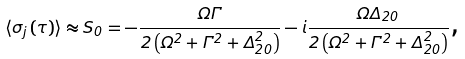<formula> <loc_0><loc_0><loc_500><loc_500>\langle \sigma _ { j } \left ( \tau \right ) \rangle \approx S _ { 0 } = - \frac { \Omega \Gamma } { 2 \left ( \Omega ^ { 2 } + \Gamma ^ { 2 } + \Delta _ { 2 0 } ^ { 2 } \right ) } - i \frac { \Omega \Delta _ { 2 0 } } { 2 \left ( \Omega ^ { 2 } + \Gamma ^ { 2 } + \Delta _ { 2 0 } ^ { 2 } \right ) } \text {,}</formula> 